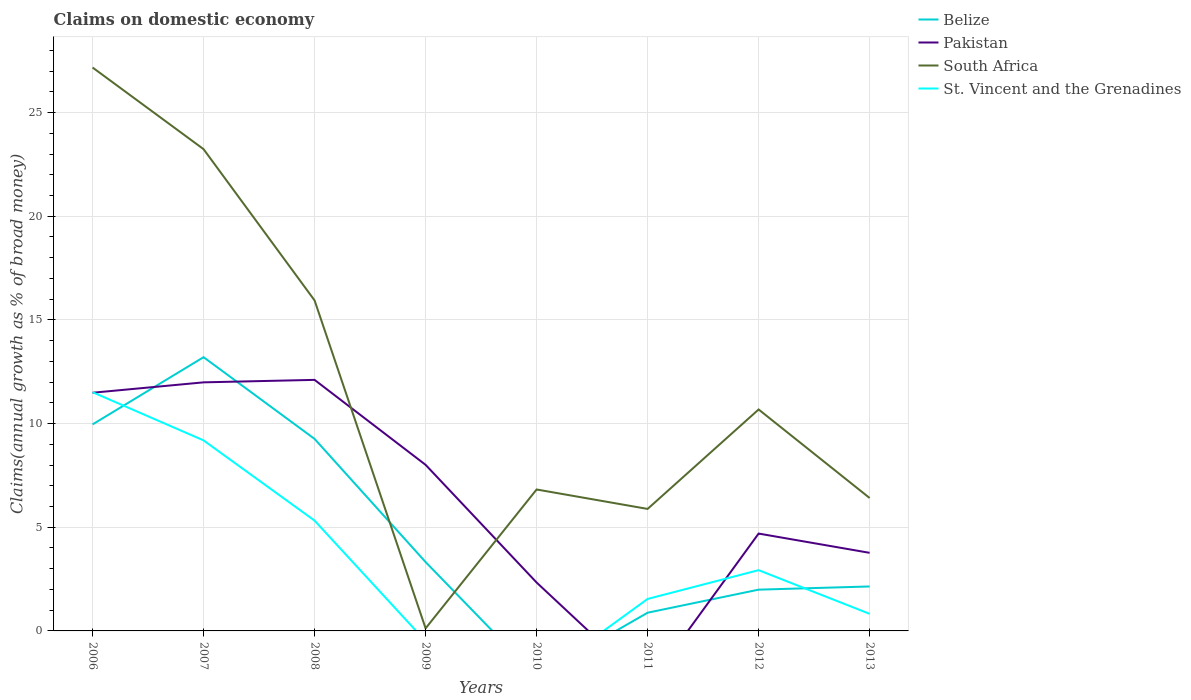How many different coloured lines are there?
Provide a succinct answer. 4. Across all years, what is the maximum percentage of broad money claimed on domestic economy in South Africa?
Keep it short and to the point. 0.12. What is the total percentage of broad money claimed on domestic economy in South Africa in the graph?
Keep it short and to the point. 21.29. What is the difference between the highest and the second highest percentage of broad money claimed on domestic economy in St. Vincent and the Grenadines?
Keep it short and to the point. 11.51. Is the percentage of broad money claimed on domestic economy in Pakistan strictly greater than the percentage of broad money claimed on domestic economy in South Africa over the years?
Offer a terse response. No. How many lines are there?
Offer a terse response. 4. How many years are there in the graph?
Your answer should be very brief. 8. Are the values on the major ticks of Y-axis written in scientific E-notation?
Provide a succinct answer. No. Does the graph contain grids?
Your answer should be very brief. Yes. How many legend labels are there?
Your answer should be very brief. 4. How are the legend labels stacked?
Provide a short and direct response. Vertical. What is the title of the graph?
Offer a terse response. Claims on domestic economy. What is the label or title of the X-axis?
Provide a succinct answer. Years. What is the label or title of the Y-axis?
Keep it short and to the point. Claims(annual growth as % of broad money). What is the Claims(annual growth as % of broad money) in Belize in 2006?
Keep it short and to the point. 9.96. What is the Claims(annual growth as % of broad money) in Pakistan in 2006?
Your answer should be compact. 11.49. What is the Claims(annual growth as % of broad money) in South Africa in 2006?
Offer a very short reply. 27.17. What is the Claims(annual growth as % of broad money) in St. Vincent and the Grenadines in 2006?
Your response must be concise. 11.51. What is the Claims(annual growth as % of broad money) in Belize in 2007?
Provide a succinct answer. 13.2. What is the Claims(annual growth as % of broad money) in Pakistan in 2007?
Give a very brief answer. 11.99. What is the Claims(annual growth as % of broad money) of South Africa in 2007?
Provide a short and direct response. 23.23. What is the Claims(annual growth as % of broad money) of St. Vincent and the Grenadines in 2007?
Provide a succinct answer. 9.19. What is the Claims(annual growth as % of broad money) in Belize in 2008?
Offer a very short reply. 9.26. What is the Claims(annual growth as % of broad money) of Pakistan in 2008?
Provide a short and direct response. 12.11. What is the Claims(annual growth as % of broad money) of South Africa in 2008?
Make the answer very short. 15.94. What is the Claims(annual growth as % of broad money) in St. Vincent and the Grenadines in 2008?
Give a very brief answer. 5.32. What is the Claims(annual growth as % of broad money) of Belize in 2009?
Give a very brief answer. 3.32. What is the Claims(annual growth as % of broad money) in Pakistan in 2009?
Provide a succinct answer. 8.01. What is the Claims(annual growth as % of broad money) of South Africa in 2009?
Your answer should be very brief. 0.12. What is the Claims(annual growth as % of broad money) of Belize in 2010?
Your answer should be very brief. 0. What is the Claims(annual growth as % of broad money) of Pakistan in 2010?
Your answer should be very brief. 2.33. What is the Claims(annual growth as % of broad money) of South Africa in 2010?
Provide a short and direct response. 6.82. What is the Claims(annual growth as % of broad money) of Belize in 2011?
Ensure brevity in your answer.  0.88. What is the Claims(annual growth as % of broad money) in South Africa in 2011?
Keep it short and to the point. 5.88. What is the Claims(annual growth as % of broad money) of St. Vincent and the Grenadines in 2011?
Your answer should be very brief. 1.54. What is the Claims(annual growth as % of broad money) in Belize in 2012?
Offer a terse response. 1.99. What is the Claims(annual growth as % of broad money) in Pakistan in 2012?
Provide a succinct answer. 4.7. What is the Claims(annual growth as % of broad money) in South Africa in 2012?
Ensure brevity in your answer.  10.68. What is the Claims(annual growth as % of broad money) in St. Vincent and the Grenadines in 2012?
Give a very brief answer. 2.93. What is the Claims(annual growth as % of broad money) of Belize in 2013?
Offer a very short reply. 2.14. What is the Claims(annual growth as % of broad money) of Pakistan in 2013?
Offer a terse response. 3.77. What is the Claims(annual growth as % of broad money) of South Africa in 2013?
Provide a succinct answer. 6.41. What is the Claims(annual growth as % of broad money) of St. Vincent and the Grenadines in 2013?
Offer a very short reply. 0.82. Across all years, what is the maximum Claims(annual growth as % of broad money) in Belize?
Your answer should be very brief. 13.2. Across all years, what is the maximum Claims(annual growth as % of broad money) of Pakistan?
Your answer should be compact. 12.11. Across all years, what is the maximum Claims(annual growth as % of broad money) in South Africa?
Provide a short and direct response. 27.17. Across all years, what is the maximum Claims(annual growth as % of broad money) of St. Vincent and the Grenadines?
Ensure brevity in your answer.  11.51. Across all years, what is the minimum Claims(annual growth as % of broad money) in Belize?
Offer a very short reply. 0. Across all years, what is the minimum Claims(annual growth as % of broad money) of Pakistan?
Your answer should be compact. 0. Across all years, what is the minimum Claims(annual growth as % of broad money) of South Africa?
Provide a succinct answer. 0.12. What is the total Claims(annual growth as % of broad money) in Belize in the graph?
Ensure brevity in your answer.  40.76. What is the total Claims(annual growth as % of broad money) of Pakistan in the graph?
Your response must be concise. 54.39. What is the total Claims(annual growth as % of broad money) of South Africa in the graph?
Ensure brevity in your answer.  96.26. What is the total Claims(annual growth as % of broad money) of St. Vincent and the Grenadines in the graph?
Ensure brevity in your answer.  31.32. What is the difference between the Claims(annual growth as % of broad money) of Belize in 2006 and that in 2007?
Your answer should be very brief. -3.24. What is the difference between the Claims(annual growth as % of broad money) of Pakistan in 2006 and that in 2007?
Ensure brevity in your answer.  -0.5. What is the difference between the Claims(annual growth as % of broad money) in South Africa in 2006 and that in 2007?
Offer a terse response. 3.94. What is the difference between the Claims(annual growth as % of broad money) in St. Vincent and the Grenadines in 2006 and that in 2007?
Ensure brevity in your answer.  2.32. What is the difference between the Claims(annual growth as % of broad money) of Belize in 2006 and that in 2008?
Offer a very short reply. 0.7. What is the difference between the Claims(annual growth as % of broad money) in Pakistan in 2006 and that in 2008?
Offer a terse response. -0.62. What is the difference between the Claims(annual growth as % of broad money) of South Africa in 2006 and that in 2008?
Make the answer very short. 11.23. What is the difference between the Claims(annual growth as % of broad money) in St. Vincent and the Grenadines in 2006 and that in 2008?
Offer a very short reply. 6.19. What is the difference between the Claims(annual growth as % of broad money) in Belize in 2006 and that in 2009?
Offer a very short reply. 6.64. What is the difference between the Claims(annual growth as % of broad money) of Pakistan in 2006 and that in 2009?
Provide a short and direct response. 3.48. What is the difference between the Claims(annual growth as % of broad money) in South Africa in 2006 and that in 2009?
Your answer should be very brief. 27.05. What is the difference between the Claims(annual growth as % of broad money) in Pakistan in 2006 and that in 2010?
Your response must be concise. 9.15. What is the difference between the Claims(annual growth as % of broad money) of South Africa in 2006 and that in 2010?
Provide a succinct answer. 20.35. What is the difference between the Claims(annual growth as % of broad money) in Belize in 2006 and that in 2011?
Your answer should be very brief. 9.08. What is the difference between the Claims(annual growth as % of broad money) in South Africa in 2006 and that in 2011?
Ensure brevity in your answer.  21.29. What is the difference between the Claims(annual growth as % of broad money) of St. Vincent and the Grenadines in 2006 and that in 2011?
Your response must be concise. 9.97. What is the difference between the Claims(annual growth as % of broad money) of Belize in 2006 and that in 2012?
Ensure brevity in your answer.  7.97. What is the difference between the Claims(annual growth as % of broad money) of Pakistan in 2006 and that in 2012?
Make the answer very short. 6.79. What is the difference between the Claims(annual growth as % of broad money) in South Africa in 2006 and that in 2012?
Ensure brevity in your answer.  16.49. What is the difference between the Claims(annual growth as % of broad money) of St. Vincent and the Grenadines in 2006 and that in 2012?
Provide a short and direct response. 8.58. What is the difference between the Claims(annual growth as % of broad money) in Belize in 2006 and that in 2013?
Your answer should be very brief. 7.81. What is the difference between the Claims(annual growth as % of broad money) in Pakistan in 2006 and that in 2013?
Ensure brevity in your answer.  7.72. What is the difference between the Claims(annual growth as % of broad money) of South Africa in 2006 and that in 2013?
Keep it short and to the point. 20.76. What is the difference between the Claims(annual growth as % of broad money) in St. Vincent and the Grenadines in 2006 and that in 2013?
Provide a succinct answer. 10.69. What is the difference between the Claims(annual growth as % of broad money) in Belize in 2007 and that in 2008?
Your answer should be compact. 3.94. What is the difference between the Claims(annual growth as % of broad money) of Pakistan in 2007 and that in 2008?
Ensure brevity in your answer.  -0.12. What is the difference between the Claims(annual growth as % of broad money) of South Africa in 2007 and that in 2008?
Offer a terse response. 7.29. What is the difference between the Claims(annual growth as % of broad money) in St. Vincent and the Grenadines in 2007 and that in 2008?
Your answer should be compact. 3.87. What is the difference between the Claims(annual growth as % of broad money) of Belize in 2007 and that in 2009?
Ensure brevity in your answer.  9.88. What is the difference between the Claims(annual growth as % of broad money) of Pakistan in 2007 and that in 2009?
Provide a succinct answer. 3.98. What is the difference between the Claims(annual growth as % of broad money) in South Africa in 2007 and that in 2009?
Give a very brief answer. 23.11. What is the difference between the Claims(annual growth as % of broad money) of Pakistan in 2007 and that in 2010?
Provide a succinct answer. 9.65. What is the difference between the Claims(annual growth as % of broad money) in South Africa in 2007 and that in 2010?
Give a very brief answer. 16.41. What is the difference between the Claims(annual growth as % of broad money) of Belize in 2007 and that in 2011?
Make the answer very short. 12.32. What is the difference between the Claims(annual growth as % of broad money) in South Africa in 2007 and that in 2011?
Offer a very short reply. 17.35. What is the difference between the Claims(annual growth as % of broad money) of St. Vincent and the Grenadines in 2007 and that in 2011?
Provide a short and direct response. 7.65. What is the difference between the Claims(annual growth as % of broad money) in Belize in 2007 and that in 2012?
Offer a terse response. 11.21. What is the difference between the Claims(annual growth as % of broad money) in Pakistan in 2007 and that in 2012?
Your response must be concise. 7.29. What is the difference between the Claims(annual growth as % of broad money) in South Africa in 2007 and that in 2012?
Your answer should be very brief. 12.55. What is the difference between the Claims(annual growth as % of broad money) in St. Vincent and the Grenadines in 2007 and that in 2012?
Provide a short and direct response. 6.26. What is the difference between the Claims(annual growth as % of broad money) of Belize in 2007 and that in 2013?
Your answer should be compact. 11.06. What is the difference between the Claims(annual growth as % of broad money) in Pakistan in 2007 and that in 2013?
Offer a very short reply. 8.22. What is the difference between the Claims(annual growth as % of broad money) of South Africa in 2007 and that in 2013?
Your answer should be compact. 16.82. What is the difference between the Claims(annual growth as % of broad money) of St. Vincent and the Grenadines in 2007 and that in 2013?
Your answer should be very brief. 8.36. What is the difference between the Claims(annual growth as % of broad money) in Belize in 2008 and that in 2009?
Offer a terse response. 5.94. What is the difference between the Claims(annual growth as % of broad money) of Pakistan in 2008 and that in 2009?
Provide a succinct answer. 4.1. What is the difference between the Claims(annual growth as % of broad money) of South Africa in 2008 and that in 2009?
Provide a succinct answer. 15.81. What is the difference between the Claims(annual growth as % of broad money) in Pakistan in 2008 and that in 2010?
Provide a succinct answer. 9.77. What is the difference between the Claims(annual growth as % of broad money) of South Africa in 2008 and that in 2010?
Ensure brevity in your answer.  9.12. What is the difference between the Claims(annual growth as % of broad money) in Belize in 2008 and that in 2011?
Provide a short and direct response. 8.38. What is the difference between the Claims(annual growth as % of broad money) of South Africa in 2008 and that in 2011?
Provide a short and direct response. 10.06. What is the difference between the Claims(annual growth as % of broad money) of St. Vincent and the Grenadines in 2008 and that in 2011?
Keep it short and to the point. 3.78. What is the difference between the Claims(annual growth as % of broad money) in Belize in 2008 and that in 2012?
Make the answer very short. 7.27. What is the difference between the Claims(annual growth as % of broad money) of Pakistan in 2008 and that in 2012?
Keep it short and to the point. 7.41. What is the difference between the Claims(annual growth as % of broad money) of South Africa in 2008 and that in 2012?
Ensure brevity in your answer.  5.26. What is the difference between the Claims(annual growth as % of broad money) in St. Vincent and the Grenadines in 2008 and that in 2012?
Keep it short and to the point. 2.39. What is the difference between the Claims(annual growth as % of broad money) of Belize in 2008 and that in 2013?
Ensure brevity in your answer.  7.12. What is the difference between the Claims(annual growth as % of broad money) in Pakistan in 2008 and that in 2013?
Offer a very short reply. 8.34. What is the difference between the Claims(annual growth as % of broad money) of South Africa in 2008 and that in 2013?
Make the answer very short. 9.53. What is the difference between the Claims(annual growth as % of broad money) of St. Vincent and the Grenadines in 2008 and that in 2013?
Keep it short and to the point. 4.5. What is the difference between the Claims(annual growth as % of broad money) of Pakistan in 2009 and that in 2010?
Offer a very short reply. 5.68. What is the difference between the Claims(annual growth as % of broad money) of South Africa in 2009 and that in 2010?
Ensure brevity in your answer.  -6.7. What is the difference between the Claims(annual growth as % of broad money) in Belize in 2009 and that in 2011?
Ensure brevity in your answer.  2.44. What is the difference between the Claims(annual growth as % of broad money) in South Africa in 2009 and that in 2011?
Provide a short and direct response. -5.76. What is the difference between the Claims(annual growth as % of broad money) in Belize in 2009 and that in 2012?
Keep it short and to the point. 1.33. What is the difference between the Claims(annual growth as % of broad money) of Pakistan in 2009 and that in 2012?
Give a very brief answer. 3.31. What is the difference between the Claims(annual growth as % of broad money) of South Africa in 2009 and that in 2012?
Provide a short and direct response. -10.56. What is the difference between the Claims(annual growth as % of broad money) of Belize in 2009 and that in 2013?
Keep it short and to the point. 1.18. What is the difference between the Claims(annual growth as % of broad money) of Pakistan in 2009 and that in 2013?
Keep it short and to the point. 4.24. What is the difference between the Claims(annual growth as % of broad money) of South Africa in 2009 and that in 2013?
Ensure brevity in your answer.  -6.29. What is the difference between the Claims(annual growth as % of broad money) in South Africa in 2010 and that in 2011?
Keep it short and to the point. 0.94. What is the difference between the Claims(annual growth as % of broad money) of Pakistan in 2010 and that in 2012?
Your answer should be compact. -2.36. What is the difference between the Claims(annual growth as % of broad money) of South Africa in 2010 and that in 2012?
Your answer should be compact. -3.86. What is the difference between the Claims(annual growth as % of broad money) in Pakistan in 2010 and that in 2013?
Keep it short and to the point. -1.43. What is the difference between the Claims(annual growth as % of broad money) of South Africa in 2010 and that in 2013?
Your response must be concise. 0.41. What is the difference between the Claims(annual growth as % of broad money) of Belize in 2011 and that in 2012?
Your answer should be compact. -1.11. What is the difference between the Claims(annual growth as % of broad money) in South Africa in 2011 and that in 2012?
Provide a short and direct response. -4.8. What is the difference between the Claims(annual growth as % of broad money) of St. Vincent and the Grenadines in 2011 and that in 2012?
Your response must be concise. -1.39. What is the difference between the Claims(annual growth as % of broad money) in Belize in 2011 and that in 2013?
Give a very brief answer. -1.27. What is the difference between the Claims(annual growth as % of broad money) in South Africa in 2011 and that in 2013?
Your response must be concise. -0.53. What is the difference between the Claims(annual growth as % of broad money) in St. Vincent and the Grenadines in 2011 and that in 2013?
Your answer should be very brief. 0.72. What is the difference between the Claims(annual growth as % of broad money) of Belize in 2012 and that in 2013?
Offer a very short reply. -0.15. What is the difference between the Claims(annual growth as % of broad money) in Pakistan in 2012 and that in 2013?
Keep it short and to the point. 0.93. What is the difference between the Claims(annual growth as % of broad money) in South Africa in 2012 and that in 2013?
Provide a succinct answer. 4.27. What is the difference between the Claims(annual growth as % of broad money) in St. Vincent and the Grenadines in 2012 and that in 2013?
Provide a succinct answer. 2.11. What is the difference between the Claims(annual growth as % of broad money) in Belize in 2006 and the Claims(annual growth as % of broad money) in Pakistan in 2007?
Provide a short and direct response. -2.03. What is the difference between the Claims(annual growth as % of broad money) of Belize in 2006 and the Claims(annual growth as % of broad money) of South Africa in 2007?
Offer a terse response. -13.27. What is the difference between the Claims(annual growth as % of broad money) of Belize in 2006 and the Claims(annual growth as % of broad money) of St. Vincent and the Grenadines in 2007?
Offer a terse response. 0.77. What is the difference between the Claims(annual growth as % of broad money) of Pakistan in 2006 and the Claims(annual growth as % of broad money) of South Africa in 2007?
Provide a succinct answer. -11.75. What is the difference between the Claims(annual growth as % of broad money) of Pakistan in 2006 and the Claims(annual growth as % of broad money) of St. Vincent and the Grenadines in 2007?
Your response must be concise. 2.3. What is the difference between the Claims(annual growth as % of broad money) in South Africa in 2006 and the Claims(annual growth as % of broad money) in St. Vincent and the Grenadines in 2007?
Keep it short and to the point. 17.98. What is the difference between the Claims(annual growth as % of broad money) of Belize in 2006 and the Claims(annual growth as % of broad money) of Pakistan in 2008?
Provide a succinct answer. -2.15. What is the difference between the Claims(annual growth as % of broad money) of Belize in 2006 and the Claims(annual growth as % of broad money) of South Africa in 2008?
Offer a terse response. -5.98. What is the difference between the Claims(annual growth as % of broad money) in Belize in 2006 and the Claims(annual growth as % of broad money) in St. Vincent and the Grenadines in 2008?
Make the answer very short. 4.64. What is the difference between the Claims(annual growth as % of broad money) in Pakistan in 2006 and the Claims(annual growth as % of broad money) in South Africa in 2008?
Provide a short and direct response. -4.45. What is the difference between the Claims(annual growth as % of broad money) in Pakistan in 2006 and the Claims(annual growth as % of broad money) in St. Vincent and the Grenadines in 2008?
Make the answer very short. 6.17. What is the difference between the Claims(annual growth as % of broad money) in South Africa in 2006 and the Claims(annual growth as % of broad money) in St. Vincent and the Grenadines in 2008?
Ensure brevity in your answer.  21.85. What is the difference between the Claims(annual growth as % of broad money) in Belize in 2006 and the Claims(annual growth as % of broad money) in Pakistan in 2009?
Ensure brevity in your answer.  1.95. What is the difference between the Claims(annual growth as % of broad money) of Belize in 2006 and the Claims(annual growth as % of broad money) of South Africa in 2009?
Offer a terse response. 9.84. What is the difference between the Claims(annual growth as % of broad money) of Pakistan in 2006 and the Claims(annual growth as % of broad money) of South Africa in 2009?
Your answer should be very brief. 11.36. What is the difference between the Claims(annual growth as % of broad money) of Belize in 2006 and the Claims(annual growth as % of broad money) of Pakistan in 2010?
Ensure brevity in your answer.  7.62. What is the difference between the Claims(annual growth as % of broad money) of Belize in 2006 and the Claims(annual growth as % of broad money) of South Africa in 2010?
Provide a succinct answer. 3.14. What is the difference between the Claims(annual growth as % of broad money) in Pakistan in 2006 and the Claims(annual growth as % of broad money) in South Africa in 2010?
Your response must be concise. 4.67. What is the difference between the Claims(annual growth as % of broad money) of Belize in 2006 and the Claims(annual growth as % of broad money) of South Africa in 2011?
Make the answer very short. 4.08. What is the difference between the Claims(annual growth as % of broad money) of Belize in 2006 and the Claims(annual growth as % of broad money) of St. Vincent and the Grenadines in 2011?
Ensure brevity in your answer.  8.42. What is the difference between the Claims(annual growth as % of broad money) of Pakistan in 2006 and the Claims(annual growth as % of broad money) of South Africa in 2011?
Keep it short and to the point. 5.6. What is the difference between the Claims(annual growth as % of broad money) in Pakistan in 2006 and the Claims(annual growth as % of broad money) in St. Vincent and the Grenadines in 2011?
Keep it short and to the point. 9.94. What is the difference between the Claims(annual growth as % of broad money) in South Africa in 2006 and the Claims(annual growth as % of broad money) in St. Vincent and the Grenadines in 2011?
Provide a succinct answer. 25.63. What is the difference between the Claims(annual growth as % of broad money) in Belize in 2006 and the Claims(annual growth as % of broad money) in Pakistan in 2012?
Offer a terse response. 5.26. What is the difference between the Claims(annual growth as % of broad money) in Belize in 2006 and the Claims(annual growth as % of broad money) in South Africa in 2012?
Your answer should be very brief. -0.72. What is the difference between the Claims(annual growth as % of broad money) in Belize in 2006 and the Claims(annual growth as % of broad money) in St. Vincent and the Grenadines in 2012?
Your response must be concise. 7.03. What is the difference between the Claims(annual growth as % of broad money) of Pakistan in 2006 and the Claims(annual growth as % of broad money) of South Africa in 2012?
Your answer should be very brief. 0.81. What is the difference between the Claims(annual growth as % of broad money) of Pakistan in 2006 and the Claims(annual growth as % of broad money) of St. Vincent and the Grenadines in 2012?
Offer a terse response. 8.56. What is the difference between the Claims(annual growth as % of broad money) of South Africa in 2006 and the Claims(annual growth as % of broad money) of St. Vincent and the Grenadines in 2012?
Provide a succinct answer. 24.24. What is the difference between the Claims(annual growth as % of broad money) of Belize in 2006 and the Claims(annual growth as % of broad money) of Pakistan in 2013?
Your answer should be compact. 6.19. What is the difference between the Claims(annual growth as % of broad money) in Belize in 2006 and the Claims(annual growth as % of broad money) in South Africa in 2013?
Keep it short and to the point. 3.55. What is the difference between the Claims(annual growth as % of broad money) in Belize in 2006 and the Claims(annual growth as % of broad money) in St. Vincent and the Grenadines in 2013?
Provide a short and direct response. 9.13. What is the difference between the Claims(annual growth as % of broad money) of Pakistan in 2006 and the Claims(annual growth as % of broad money) of South Africa in 2013?
Your response must be concise. 5.08. What is the difference between the Claims(annual growth as % of broad money) of Pakistan in 2006 and the Claims(annual growth as % of broad money) of St. Vincent and the Grenadines in 2013?
Keep it short and to the point. 10.66. What is the difference between the Claims(annual growth as % of broad money) of South Africa in 2006 and the Claims(annual growth as % of broad money) of St. Vincent and the Grenadines in 2013?
Provide a short and direct response. 26.35. What is the difference between the Claims(annual growth as % of broad money) of Belize in 2007 and the Claims(annual growth as % of broad money) of Pakistan in 2008?
Keep it short and to the point. 1.09. What is the difference between the Claims(annual growth as % of broad money) in Belize in 2007 and the Claims(annual growth as % of broad money) in South Africa in 2008?
Your answer should be very brief. -2.74. What is the difference between the Claims(annual growth as % of broad money) of Belize in 2007 and the Claims(annual growth as % of broad money) of St. Vincent and the Grenadines in 2008?
Offer a terse response. 7.88. What is the difference between the Claims(annual growth as % of broad money) of Pakistan in 2007 and the Claims(annual growth as % of broad money) of South Africa in 2008?
Your answer should be very brief. -3.95. What is the difference between the Claims(annual growth as % of broad money) of Pakistan in 2007 and the Claims(annual growth as % of broad money) of St. Vincent and the Grenadines in 2008?
Your answer should be very brief. 6.67. What is the difference between the Claims(annual growth as % of broad money) of South Africa in 2007 and the Claims(annual growth as % of broad money) of St. Vincent and the Grenadines in 2008?
Your response must be concise. 17.91. What is the difference between the Claims(annual growth as % of broad money) of Belize in 2007 and the Claims(annual growth as % of broad money) of Pakistan in 2009?
Offer a terse response. 5.19. What is the difference between the Claims(annual growth as % of broad money) of Belize in 2007 and the Claims(annual growth as % of broad money) of South Africa in 2009?
Make the answer very short. 13.08. What is the difference between the Claims(annual growth as % of broad money) of Pakistan in 2007 and the Claims(annual growth as % of broad money) of South Africa in 2009?
Offer a very short reply. 11.86. What is the difference between the Claims(annual growth as % of broad money) of Belize in 2007 and the Claims(annual growth as % of broad money) of Pakistan in 2010?
Ensure brevity in your answer.  10.87. What is the difference between the Claims(annual growth as % of broad money) of Belize in 2007 and the Claims(annual growth as % of broad money) of South Africa in 2010?
Offer a very short reply. 6.38. What is the difference between the Claims(annual growth as % of broad money) of Pakistan in 2007 and the Claims(annual growth as % of broad money) of South Africa in 2010?
Provide a short and direct response. 5.17. What is the difference between the Claims(annual growth as % of broad money) of Belize in 2007 and the Claims(annual growth as % of broad money) of South Africa in 2011?
Give a very brief answer. 7.32. What is the difference between the Claims(annual growth as % of broad money) of Belize in 2007 and the Claims(annual growth as % of broad money) of St. Vincent and the Grenadines in 2011?
Your response must be concise. 11.66. What is the difference between the Claims(annual growth as % of broad money) in Pakistan in 2007 and the Claims(annual growth as % of broad money) in South Africa in 2011?
Your answer should be compact. 6.1. What is the difference between the Claims(annual growth as % of broad money) in Pakistan in 2007 and the Claims(annual growth as % of broad money) in St. Vincent and the Grenadines in 2011?
Make the answer very short. 10.45. What is the difference between the Claims(annual growth as % of broad money) of South Africa in 2007 and the Claims(annual growth as % of broad money) of St. Vincent and the Grenadines in 2011?
Offer a terse response. 21.69. What is the difference between the Claims(annual growth as % of broad money) of Belize in 2007 and the Claims(annual growth as % of broad money) of Pakistan in 2012?
Your response must be concise. 8.51. What is the difference between the Claims(annual growth as % of broad money) in Belize in 2007 and the Claims(annual growth as % of broad money) in South Africa in 2012?
Your response must be concise. 2.52. What is the difference between the Claims(annual growth as % of broad money) of Belize in 2007 and the Claims(annual growth as % of broad money) of St. Vincent and the Grenadines in 2012?
Your answer should be very brief. 10.27. What is the difference between the Claims(annual growth as % of broad money) of Pakistan in 2007 and the Claims(annual growth as % of broad money) of South Africa in 2012?
Offer a terse response. 1.31. What is the difference between the Claims(annual growth as % of broad money) of Pakistan in 2007 and the Claims(annual growth as % of broad money) of St. Vincent and the Grenadines in 2012?
Make the answer very short. 9.06. What is the difference between the Claims(annual growth as % of broad money) in South Africa in 2007 and the Claims(annual growth as % of broad money) in St. Vincent and the Grenadines in 2012?
Ensure brevity in your answer.  20.3. What is the difference between the Claims(annual growth as % of broad money) in Belize in 2007 and the Claims(annual growth as % of broad money) in Pakistan in 2013?
Your answer should be compact. 9.44. What is the difference between the Claims(annual growth as % of broad money) in Belize in 2007 and the Claims(annual growth as % of broad money) in South Africa in 2013?
Ensure brevity in your answer.  6.79. What is the difference between the Claims(annual growth as % of broad money) of Belize in 2007 and the Claims(annual growth as % of broad money) of St. Vincent and the Grenadines in 2013?
Give a very brief answer. 12.38. What is the difference between the Claims(annual growth as % of broad money) of Pakistan in 2007 and the Claims(annual growth as % of broad money) of South Africa in 2013?
Ensure brevity in your answer.  5.58. What is the difference between the Claims(annual growth as % of broad money) in Pakistan in 2007 and the Claims(annual growth as % of broad money) in St. Vincent and the Grenadines in 2013?
Provide a succinct answer. 11.16. What is the difference between the Claims(annual growth as % of broad money) of South Africa in 2007 and the Claims(annual growth as % of broad money) of St. Vincent and the Grenadines in 2013?
Your answer should be compact. 22.41. What is the difference between the Claims(annual growth as % of broad money) of Belize in 2008 and the Claims(annual growth as % of broad money) of Pakistan in 2009?
Your answer should be very brief. 1.25. What is the difference between the Claims(annual growth as % of broad money) of Belize in 2008 and the Claims(annual growth as % of broad money) of South Africa in 2009?
Keep it short and to the point. 9.14. What is the difference between the Claims(annual growth as % of broad money) in Pakistan in 2008 and the Claims(annual growth as % of broad money) in South Africa in 2009?
Ensure brevity in your answer.  11.98. What is the difference between the Claims(annual growth as % of broad money) in Belize in 2008 and the Claims(annual growth as % of broad money) in Pakistan in 2010?
Offer a very short reply. 6.93. What is the difference between the Claims(annual growth as % of broad money) of Belize in 2008 and the Claims(annual growth as % of broad money) of South Africa in 2010?
Your response must be concise. 2.44. What is the difference between the Claims(annual growth as % of broad money) of Pakistan in 2008 and the Claims(annual growth as % of broad money) of South Africa in 2010?
Your answer should be very brief. 5.29. What is the difference between the Claims(annual growth as % of broad money) of Belize in 2008 and the Claims(annual growth as % of broad money) of South Africa in 2011?
Make the answer very short. 3.38. What is the difference between the Claims(annual growth as % of broad money) of Belize in 2008 and the Claims(annual growth as % of broad money) of St. Vincent and the Grenadines in 2011?
Keep it short and to the point. 7.72. What is the difference between the Claims(annual growth as % of broad money) in Pakistan in 2008 and the Claims(annual growth as % of broad money) in South Africa in 2011?
Offer a very short reply. 6.22. What is the difference between the Claims(annual growth as % of broad money) of Pakistan in 2008 and the Claims(annual growth as % of broad money) of St. Vincent and the Grenadines in 2011?
Keep it short and to the point. 10.56. What is the difference between the Claims(annual growth as % of broad money) of South Africa in 2008 and the Claims(annual growth as % of broad money) of St. Vincent and the Grenadines in 2011?
Ensure brevity in your answer.  14.4. What is the difference between the Claims(annual growth as % of broad money) in Belize in 2008 and the Claims(annual growth as % of broad money) in Pakistan in 2012?
Your response must be concise. 4.56. What is the difference between the Claims(annual growth as % of broad money) of Belize in 2008 and the Claims(annual growth as % of broad money) of South Africa in 2012?
Offer a very short reply. -1.42. What is the difference between the Claims(annual growth as % of broad money) of Belize in 2008 and the Claims(annual growth as % of broad money) of St. Vincent and the Grenadines in 2012?
Give a very brief answer. 6.33. What is the difference between the Claims(annual growth as % of broad money) of Pakistan in 2008 and the Claims(annual growth as % of broad money) of South Africa in 2012?
Ensure brevity in your answer.  1.43. What is the difference between the Claims(annual growth as % of broad money) of Pakistan in 2008 and the Claims(annual growth as % of broad money) of St. Vincent and the Grenadines in 2012?
Keep it short and to the point. 9.18. What is the difference between the Claims(annual growth as % of broad money) in South Africa in 2008 and the Claims(annual growth as % of broad money) in St. Vincent and the Grenadines in 2012?
Your answer should be very brief. 13.01. What is the difference between the Claims(annual growth as % of broad money) in Belize in 2008 and the Claims(annual growth as % of broad money) in Pakistan in 2013?
Your response must be concise. 5.49. What is the difference between the Claims(annual growth as % of broad money) in Belize in 2008 and the Claims(annual growth as % of broad money) in South Africa in 2013?
Your response must be concise. 2.85. What is the difference between the Claims(annual growth as % of broad money) in Belize in 2008 and the Claims(annual growth as % of broad money) in St. Vincent and the Grenadines in 2013?
Provide a succinct answer. 8.44. What is the difference between the Claims(annual growth as % of broad money) in Pakistan in 2008 and the Claims(annual growth as % of broad money) in South Africa in 2013?
Offer a terse response. 5.7. What is the difference between the Claims(annual growth as % of broad money) of Pakistan in 2008 and the Claims(annual growth as % of broad money) of St. Vincent and the Grenadines in 2013?
Your response must be concise. 11.28. What is the difference between the Claims(annual growth as % of broad money) of South Africa in 2008 and the Claims(annual growth as % of broad money) of St. Vincent and the Grenadines in 2013?
Provide a succinct answer. 15.11. What is the difference between the Claims(annual growth as % of broad money) in Belize in 2009 and the Claims(annual growth as % of broad money) in Pakistan in 2010?
Your answer should be compact. 0.99. What is the difference between the Claims(annual growth as % of broad money) in Belize in 2009 and the Claims(annual growth as % of broad money) in South Africa in 2010?
Make the answer very short. -3.5. What is the difference between the Claims(annual growth as % of broad money) of Pakistan in 2009 and the Claims(annual growth as % of broad money) of South Africa in 2010?
Provide a short and direct response. 1.19. What is the difference between the Claims(annual growth as % of broad money) in Belize in 2009 and the Claims(annual growth as % of broad money) in South Africa in 2011?
Give a very brief answer. -2.56. What is the difference between the Claims(annual growth as % of broad money) of Belize in 2009 and the Claims(annual growth as % of broad money) of St. Vincent and the Grenadines in 2011?
Your answer should be very brief. 1.78. What is the difference between the Claims(annual growth as % of broad money) of Pakistan in 2009 and the Claims(annual growth as % of broad money) of South Africa in 2011?
Offer a very short reply. 2.13. What is the difference between the Claims(annual growth as % of broad money) in Pakistan in 2009 and the Claims(annual growth as % of broad money) in St. Vincent and the Grenadines in 2011?
Provide a short and direct response. 6.47. What is the difference between the Claims(annual growth as % of broad money) in South Africa in 2009 and the Claims(annual growth as % of broad money) in St. Vincent and the Grenadines in 2011?
Keep it short and to the point. -1.42. What is the difference between the Claims(annual growth as % of broad money) of Belize in 2009 and the Claims(annual growth as % of broad money) of Pakistan in 2012?
Keep it short and to the point. -1.37. What is the difference between the Claims(annual growth as % of broad money) in Belize in 2009 and the Claims(annual growth as % of broad money) in South Africa in 2012?
Offer a terse response. -7.36. What is the difference between the Claims(annual growth as % of broad money) of Belize in 2009 and the Claims(annual growth as % of broad money) of St. Vincent and the Grenadines in 2012?
Give a very brief answer. 0.39. What is the difference between the Claims(annual growth as % of broad money) in Pakistan in 2009 and the Claims(annual growth as % of broad money) in South Africa in 2012?
Your response must be concise. -2.67. What is the difference between the Claims(annual growth as % of broad money) in Pakistan in 2009 and the Claims(annual growth as % of broad money) in St. Vincent and the Grenadines in 2012?
Provide a succinct answer. 5.08. What is the difference between the Claims(annual growth as % of broad money) of South Africa in 2009 and the Claims(annual growth as % of broad money) of St. Vincent and the Grenadines in 2012?
Make the answer very short. -2.81. What is the difference between the Claims(annual growth as % of broad money) of Belize in 2009 and the Claims(annual growth as % of broad money) of Pakistan in 2013?
Your response must be concise. -0.44. What is the difference between the Claims(annual growth as % of broad money) in Belize in 2009 and the Claims(annual growth as % of broad money) in South Africa in 2013?
Make the answer very short. -3.09. What is the difference between the Claims(annual growth as % of broad money) in Belize in 2009 and the Claims(annual growth as % of broad money) in St. Vincent and the Grenadines in 2013?
Offer a terse response. 2.5. What is the difference between the Claims(annual growth as % of broad money) in Pakistan in 2009 and the Claims(annual growth as % of broad money) in South Africa in 2013?
Ensure brevity in your answer.  1.6. What is the difference between the Claims(annual growth as % of broad money) of Pakistan in 2009 and the Claims(annual growth as % of broad money) of St. Vincent and the Grenadines in 2013?
Make the answer very short. 7.19. What is the difference between the Claims(annual growth as % of broad money) in South Africa in 2009 and the Claims(annual growth as % of broad money) in St. Vincent and the Grenadines in 2013?
Your response must be concise. -0.7. What is the difference between the Claims(annual growth as % of broad money) in Pakistan in 2010 and the Claims(annual growth as % of broad money) in South Africa in 2011?
Offer a very short reply. -3.55. What is the difference between the Claims(annual growth as % of broad money) of Pakistan in 2010 and the Claims(annual growth as % of broad money) of St. Vincent and the Grenadines in 2011?
Offer a terse response. 0.79. What is the difference between the Claims(annual growth as % of broad money) of South Africa in 2010 and the Claims(annual growth as % of broad money) of St. Vincent and the Grenadines in 2011?
Ensure brevity in your answer.  5.28. What is the difference between the Claims(annual growth as % of broad money) in Pakistan in 2010 and the Claims(annual growth as % of broad money) in South Africa in 2012?
Make the answer very short. -8.34. What is the difference between the Claims(annual growth as % of broad money) in Pakistan in 2010 and the Claims(annual growth as % of broad money) in St. Vincent and the Grenadines in 2012?
Provide a short and direct response. -0.6. What is the difference between the Claims(annual growth as % of broad money) in South Africa in 2010 and the Claims(annual growth as % of broad money) in St. Vincent and the Grenadines in 2012?
Provide a succinct answer. 3.89. What is the difference between the Claims(annual growth as % of broad money) of Pakistan in 2010 and the Claims(annual growth as % of broad money) of South Africa in 2013?
Ensure brevity in your answer.  -4.08. What is the difference between the Claims(annual growth as % of broad money) of Pakistan in 2010 and the Claims(annual growth as % of broad money) of St. Vincent and the Grenadines in 2013?
Offer a very short reply. 1.51. What is the difference between the Claims(annual growth as % of broad money) of South Africa in 2010 and the Claims(annual growth as % of broad money) of St. Vincent and the Grenadines in 2013?
Your response must be concise. 6. What is the difference between the Claims(annual growth as % of broad money) of Belize in 2011 and the Claims(annual growth as % of broad money) of Pakistan in 2012?
Your answer should be very brief. -3.82. What is the difference between the Claims(annual growth as % of broad money) of Belize in 2011 and the Claims(annual growth as % of broad money) of South Africa in 2012?
Give a very brief answer. -9.8. What is the difference between the Claims(annual growth as % of broad money) of Belize in 2011 and the Claims(annual growth as % of broad money) of St. Vincent and the Grenadines in 2012?
Your response must be concise. -2.05. What is the difference between the Claims(annual growth as % of broad money) of South Africa in 2011 and the Claims(annual growth as % of broad money) of St. Vincent and the Grenadines in 2012?
Make the answer very short. 2.95. What is the difference between the Claims(annual growth as % of broad money) of Belize in 2011 and the Claims(annual growth as % of broad money) of Pakistan in 2013?
Give a very brief answer. -2.89. What is the difference between the Claims(annual growth as % of broad money) of Belize in 2011 and the Claims(annual growth as % of broad money) of South Africa in 2013?
Ensure brevity in your answer.  -5.53. What is the difference between the Claims(annual growth as % of broad money) in Belize in 2011 and the Claims(annual growth as % of broad money) in St. Vincent and the Grenadines in 2013?
Your answer should be compact. 0.05. What is the difference between the Claims(annual growth as % of broad money) in South Africa in 2011 and the Claims(annual growth as % of broad money) in St. Vincent and the Grenadines in 2013?
Provide a short and direct response. 5.06. What is the difference between the Claims(annual growth as % of broad money) of Belize in 2012 and the Claims(annual growth as % of broad money) of Pakistan in 2013?
Keep it short and to the point. -1.78. What is the difference between the Claims(annual growth as % of broad money) in Belize in 2012 and the Claims(annual growth as % of broad money) in South Africa in 2013?
Your answer should be compact. -4.42. What is the difference between the Claims(annual growth as % of broad money) in Belize in 2012 and the Claims(annual growth as % of broad money) in St. Vincent and the Grenadines in 2013?
Ensure brevity in your answer.  1.17. What is the difference between the Claims(annual growth as % of broad money) in Pakistan in 2012 and the Claims(annual growth as % of broad money) in South Africa in 2013?
Provide a succinct answer. -1.71. What is the difference between the Claims(annual growth as % of broad money) of Pakistan in 2012 and the Claims(annual growth as % of broad money) of St. Vincent and the Grenadines in 2013?
Your answer should be compact. 3.87. What is the difference between the Claims(annual growth as % of broad money) of South Africa in 2012 and the Claims(annual growth as % of broad money) of St. Vincent and the Grenadines in 2013?
Provide a short and direct response. 9.85. What is the average Claims(annual growth as % of broad money) in Belize per year?
Offer a very short reply. 5.09. What is the average Claims(annual growth as % of broad money) of Pakistan per year?
Keep it short and to the point. 6.8. What is the average Claims(annual growth as % of broad money) of South Africa per year?
Your answer should be compact. 12.03. What is the average Claims(annual growth as % of broad money) of St. Vincent and the Grenadines per year?
Ensure brevity in your answer.  3.92. In the year 2006, what is the difference between the Claims(annual growth as % of broad money) of Belize and Claims(annual growth as % of broad money) of Pakistan?
Provide a succinct answer. -1.53. In the year 2006, what is the difference between the Claims(annual growth as % of broad money) in Belize and Claims(annual growth as % of broad money) in South Africa?
Your response must be concise. -17.21. In the year 2006, what is the difference between the Claims(annual growth as % of broad money) of Belize and Claims(annual growth as % of broad money) of St. Vincent and the Grenadines?
Your answer should be very brief. -1.55. In the year 2006, what is the difference between the Claims(annual growth as % of broad money) in Pakistan and Claims(annual growth as % of broad money) in South Africa?
Your answer should be very brief. -15.69. In the year 2006, what is the difference between the Claims(annual growth as % of broad money) in Pakistan and Claims(annual growth as % of broad money) in St. Vincent and the Grenadines?
Your answer should be very brief. -0.03. In the year 2006, what is the difference between the Claims(annual growth as % of broad money) of South Africa and Claims(annual growth as % of broad money) of St. Vincent and the Grenadines?
Give a very brief answer. 15.66. In the year 2007, what is the difference between the Claims(annual growth as % of broad money) of Belize and Claims(annual growth as % of broad money) of Pakistan?
Your answer should be compact. 1.21. In the year 2007, what is the difference between the Claims(annual growth as % of broad money) of Belize and Claims(annual growth as % of broad money) of South Africa?
Your answer should be very brief. -10.03. In the year 2007, what is the difference between the Claims(annual growth as % of broad money) in Belize and Claims(annual growth as % of broad money) in St. Vincent and the Grenadines?
Make the answer very short. 4.01. In the year 2007, what is the difference between the Claims(annual growth as % of broad money) in Pakistan and Claims(annual growth as % of broad money) in South Africa?
Provide a short and direct response. -11.25. In the year 2007, what is the difference between the Claims(annual growth as % of broad money) in Pakistan and Claims(annual growth as % of broad money) in St. Vincent and the Grenadines?
Ensure brevity in your answer.  2.8. In the year 2007, what is the difference between the Claims(annual growth as % of broad money) in South Africa and Claims(annual growth as % of broad money) in St. Vincent and the Grenadines?
Your response must be concise. 14.04. In the year 2008, what is the difference between the Claims(annual growth as % of broad money) of Belize and Claims(annual growth as % of broad money) of Pakistan?
Your response must be concise. -2.85. In the year 2008, what is the difference between the Claims(annual growth as % of broad money) of Belize and Claims(annual growth as % of broad money) of South Africa?
Your answer should be very brief. -6.68. In the year 2008, what is the difference between the Claims(annual growth as % of broad money) in Belize and Claims(annual growth as % of broad money) in St. Vincent and the Grenadines?
Give a very brief answer. 3.94. In the year 2008, what is the difference between the Claims(annual growth as % of broad money) of Pakistan and Claims(annual growth as % of broad money) of South Africa?
Your response must be concise. -3.83. In the year 2008, what is the difference between the Claims(annual growth as % of broad money) in Pakistan and Claims(annual growth as % of broad money) in St. Vincent and the Grenadines?
Your answer should be compact. 6.79. In the year 2008, what is the difference between the Claims(annual growth as % of broad money) of South Africa and Claims(annual growth as % of broad money) of St. Vincent and the Grenadines?
Ensure brevity in your answer.  10.62. In the year 2009, what is the difference between the Claims(annual growth as % of broad money) in Belize and Claims(annual growth as % of broad money) in Pakistan?
Provide a short and direct response. -4.69. In the year 2009, what is the difference between the Claims(annual growth as % of broad money) in Belize and Claims(annual growth as % of broad money) in South Africa?
Give a very brief answer. 3.2. In the year 2009, what is the difference between the Claims(annual growth as % of broad money) in Pakistan and Claims(annual growth as % of broad money) in South Africa?
Provide a succinct answer. 7.89. In the year 2010, what is the difference between the Claims(annual growth as % of broad money) of Pakistan and Claims(annual growth as % of broad money) of South Africa?
Keep it short and to the point. -4.49. In the year 2011, what is the difference between the Claims(annual growth as % of broad money) in Belize and Claims(annual growth as % of broad money) in South Africa?
Ensure brevity in your answer.  -5.01. In the year 2011, what is the difference between the Claims(annual growth as % of broad money) in Belize and Claims(annual growth as % of broad money) in St. Vincent and the Grenadines?
Your response must be concise. -0.66. In the year 2011, what is the difference between the Claims(annual growth as % of broad money) of South Africa and Claims(annual growth as % of broad money) of St. Vincent and the Grenadines?
Provide a short and direct response. 4.34. In the year 2012, what is the difference between the Claims(annual growth as % of broad money) in Belize and Claims(annual growth as % of broad money) in Pakistan?
Offer a very short reply. -2.71. In the year 2012, what is the difference between the Claims(annual growth as % of broad money) of Belize and Claims(annual growth as % of broad money) of South Africa?
Make the answer very short. -8.69. In the year 2012, what is the difference between the Claims(annual growth as % of broad money) in Belize and Claims(annual growth as % of broad money) in St. Vincent and the Grenadines?
Offer a terse response. -0.94. In the year 2012, what is the difference between the Claims(annual growth as % of broad money) of Pakistan and Claims(annual growth as % of broad money) of South Africa?
Keep it short and to the point. -5.98. In the year 2012, what is the difference between the Claims(annual growth as % of broad money) in Pakistan and Claims(annual growth as % of broad money) in St. Vincent and the Grenadines?
Keep it short and to the point. 1.77. In the year 2012, what is the difference between the Claims(annual growth as % of broad money) in South Africa and Claims(annual growth as % of broad money) in St. Vincent and the Grenadines?
Make the answer very short. 7.75. In the year 2013, what is the difference between the Claims(annual growth as % of broad money) in Belize and Claims(annual growth as % of broad money) in Pakistan?
Ensure brevity in your answer.  -1.62. In the year 2013, what is the difference between the Claims(annual growth as % of broad money) of Belize and Claims(annual growth as % of broad money) of South Africa?
Make the answer very short. -4.27. In the year 2013, what is the difference between the Claims(annual growth as % of broad money) of Belize and Claims(annual growth as % of broad money) of St. Vincent and the Grenadines?
Provide a short and direct response. 1.32. In the year 2013, what is the difference between the Claims(annual growth as % of broad money) of Pakistan and Claims(annual growth as % of broad money) of South Africa?
Ensure brevity in your answer.  -2.64. In the year 2013, what is the difference between the Claims(annual growth as % of broad money) of Pakistan and Claims(annual growth as % of broad money) of St. Vincent and the Grenadines?
Provide a succinct answer. 2.94. In the year 2013, what is the difference between the Claims(annual growth as % of broad money) of South Africa and Claims(annual growth as % of broad money) of St. Vincent and the Grenadines?
Your response must be concise. 5.59. What is the ratio of the Claims(annual growth as % of broad money) of Belize in 2006 to that in 2007?
Offer a terse response. 0.75. What is the ratio of the Claims(annual growth as % of broad money) in Pakistan in 2006 to that in 2007?
Your response must be concise. 0.96. What is the ratio of the Claims(annual growth as % of broad money) of South Africa in 2006 to that in 2007?
Give a very brief answer. 1.17. What is the ratio of the Claims(annual growth as % of broad money) of St. Vincent and the Grenadines in 2006 to that in 2007?
Your response must be concise. 1.25. What is the ratio of the Claims(annual growth as % of broad money) of Belize in 2006 to that in 2008?
Keep it short and to the point. 1.08. What is the ratio of the Claims(annual growth as % of broad money) in Pakistan in 2006 to that in 2008?
Offer a terse response. 0.95. What is the ratio of the Claims(annual growth as % of broad money) in South Africa in 2006 to that in 2008?
Offer a very short reply. 1.7. What is the ratio of the Claims(annual growth as % of broad money) of St. Vincent and the Grenadines in 2006 to that in 2008?
Provide a succinct answer. 2.16. What is the ratio of the Claims(annual growth as % of broad money) in Belize in 2006 to that in 2009?
Offer a very short reply. 3. What is the ratio of the Claims(annual growth as % of broad money) of Pakistan in 2006 to that in 2009?
Offer a very short reply. 1.43. What is the ratio of the Claims(annual growth as % of broad money) of South Africa in 2006 to that in 2009?
Provide a short and direct response. 218.48. What is the ratio of the Claims(annual growth as % of broad money) in Pakistan in 2006 to that in 2010?
Offer a very short reply. 4.92. What is the ratio of the Claims(annual growth as % of broad money) of South Africa in 2006 to that in 2010?
Give a very brief answer. 3.98. What is the ratio of the Claims(annual growth as % of broad money) of Belize in 2006 to that in 2011?
Your answer should be compact. 11.34. What is the ratio of the Claims(annual growth as % of broad money) in South Africa in 2006 to that in 2011?
Offer a terse response. 4.62. What is the ratio of the Claims(annual growth as % of broad money) of St. Vincent and the Grenadines in 2006 to that in 2011?
Give a very brief answer. 7.46. What is the ratio of the Claims(annual growth as % of broad money) of Belize in 2006 to that in 2012?
Offer a terse response. 5. What is the ratio of the Claims(annual growth as % of broad money) of Pakistan in 2006 to that in 2012?
Offer a terse response. 2.45. What is the ratio of the Claims(annual growth as % of broad money) of South Africa in 2006 to that in 2012?
Make the answer very short. 2.54. What is the ratio of the Claims(annual growth as % of broad money) of St. Vincent and the Grenadines in 2006 to that in 2012?
Your answer should be compact. 3.93. What is the ratio of the Claims(annual growth as % of broad money) of Belize in 2006 to that in 2013?
Keep it short and to the point. 4.64. What is the ratio of the Claims(annual growth as % of broad money) of Pakistan in 2006 to that in 2013?
Offer a very short reply. 3.05. What is the ratio of the Claims(annual growth as % of broad money) of South Africa in 2006 to that in 2013?
Keep it short and to the point. 4.24. What is the ratio of the Claims(annual growth as % of broad money) of St. Vincent and the Grenadines in 2006 to that in 2013?
Provide a succinct answer. 13.96. What is the ratio of the Claims(annual growth as % of broad money) in Belize in 2007 to that in 2008?
Offer a terse response. 1.43. What is the ratio of the Claims(annual growth as % of broad money) in Pakistan in 2007 to that in 2008?
Provide a succinct answer. 0.99. What is the ratio of the Claims(annual growth as % of broad money) of South Africa in 2007 to that in 2008?
Your answer should be very brief. 1.46. What is the ratio of the Claims(annual growth as % of broad money) in St. Vincent and the Grenadines in 2007 to that in 2008?
Your response must be concise. 1.73. What is the ratio of the Claims(annual growth as % of broad money) in Belize in 2007 to that in 2009?
Offer a terse response. 3.97. What is the ratio of the Claims(annual growth as % of broad money) of Pakistan in 2007 to that in 2009?
Provide a succinct answer. 1.5. What is the ratio of the Claims(annual growth as % of broad money) in South Africa in 2007 to that in 2009?
Your response must be concise. 186.82. What is the ratio of the Claims(annual growth as % of broad money) of Pakistan in 2007 to that in 2010?
Keep it short and to the point. 5.13. What is the ratio of the Claims(annual growth as % of broad money) of South Africa in 2007 to that in 2010?
Provide a succinct answer. 3.41. What is the ratio of the Claims(annual growth as % of broad money) in Belize in 2007 to that in 2011?
Offer a very short reply. 15.03. What is the ratio of the Claims(annual growth as % of broad money) of South Africa in 2007 to that in 2011?
Provide a short and direct response. 3.95. What is the ratio of the Claims(annual growth as % of broad money) of St. Vincent and the Grenadines in 2007 to that in 2011?
Provide a succinct answer. 5.96. What is the ratio of the Claims(annual growth as % of broad money) of Belize in 2007 to that in 2012?
Your answer should be very brief. 6.63. What is the ratio of the Claims(annual growth as % of broad money) of Pakistan in 2007 to that in 2012?
Give a very brief answer. 2.55. What is the ratio of the Claims(annual growth as % of broad money) in South Africa in 2007 to that in 2012?
Your response must be concise. 2.18. What is the ratio of the Claims(annual growth as % of broad money) of St. Vincent and the Grenadines in 2007 to that in 2012?
Provide a short and direct response. 3.14. What is the ratio of the Claims(annual growth as % of broad money) of Belize in 2007 to that in 2013?
Provide a succinct answer. 6.16. What is the ratio of the Claims(annual growth as % of broad money) of Pakistan in 2007 to that in 2013?
Provide a succinct answer. 3.18. What is the ratio of the Claims(annual growth as % of broad money) in South Africa in 2007 to that in 2013?
Offer a very short reply. 3.62. What is the ratio of the Claims(annual growth as % of broad money) in St. Vincent and the Grenadines in 2007 to that in 2013?
Your answer should be compact. 11.14. What is the ratio of the Claims(annual growth as % of broad money) of Belize in 2008 to that in 2009?
Make the answer very short. 2.79. What is the ratio of the Claims(annual growth as % of broad money) of Pakistan in 2008 to that in 2009?
Give a very brief answer. 1.51. What is the ratio of the Claims(annual growth as % of broad money) of South Africa in 2008 to that in 2009?
Offer a terse response. 128.16. What is the ratio of the Claims(annual growth as % of broad money) of Pakistan in 2008 to that in 2010?
Your answer should be compact. 5.19. What is the ratio of the Claims(annual growth as % of broad money) of South Africa in 2008 to that in 2010?
Offer a very short reply. 2.34. What is the ratio of the Claims(annual growth as % of broad money) in Belize in 2008 to that in 2011?
Provide a short and direct response. 10.54. What is the ratio of the Claims(annual growth as % of broad money) of South Africa in 2008 to that in 2011?
Your answer should be very brief. 2.71. What is the ratio of the Claims(annual growth as % of broad money) in St. Vincent and the Grenadines in 2008 to that in 2011?
Your answer should be compact. 3.45. What is the ratio of the Claims(annual growth as % of broad money) in Belize in 2008 to that in 2012?
Provide a short and direct response. 4.65. What is the ratio of the Claims(annual growth as % of broad money) in Pakistan in 2008 to that in 2012?
Ensure brevity in your answer.  2.58. What is the ratio of the Claims(annual growth as % of broad money) in South Africa in 2008 to that in 2012?
Make the answer very short. 1.49. What is the ratio of the Claims(annual growth as % of broad money) in St. Vincent and the Grenadines in 2008 to that in 2012?
Provide a succinct answer. 1.82. What is the ratio of the Claims(annual growth as % of broad money) in Belize in 2008 to that in 2013?
Your answer should be very brief. 4.32. What is the ratio of the Claims(annual growth as % of broad money) of Pakistan in 2008 to that in 2013?
Make the answer very short. 3.21. What is the ratio of the Claims(annual growth as % of broad money) in South Africa in 2008 to that in 2013?
Your response must be concise. 2.49. What is the ratio of the Claims(annual growth as % of broad money) of St. Vincent and the Grenadines in 2008 to that in 2013?
Your response must be concise. 6.45. What is the ratio of the Claims(annual growth as % of broad money) in Pakistan in 2009 to that in 2010?
Offer a very short reply. 3.43. What is the ratio of the Claims(annual growth as % of broad money) in South Africa in 2009 to that in 2010?
Ensure brevity in your answer.  0.02. What is the ratio of the Claims(annual growth as % of broad money) in Belize in 2009 to that in 2011?
Offer a very short reply. 3.78. What is the ratio of the Claims(annual growth as % of broad money) of South Africa in 2009 to that in 2011?
Give a very brief answer. 0.02. What is the ratio of the Claims(annual growth as % of broad money) in Belize in 2009 to that in 2012?
Offer a very short reply. 1.67. What is the ratio of the Claims(annual growth as % of broad money) in Pakistan in 2009 to that in 2012?
Your answer should be very brief. 1.71. What is the ratio of the Claims(annual growth as % of broad money) in South Africa in 2009 to that in 2012?
Make the answer very short. 0.01. What is the ratio of the Claims(annual growth as % of broad money) of Belize in 2009 to that in 2013?
Make the answer very short. 1.55. What is the ratio of the Claims(annual growth as % of broad money) of Pakistan in 2009 to that in 2013?
Make the answer very short. 2.13. What is the ratio of the Claims(annual growth as % of broad money) in South Africa in 2009 to that in 2013?
Your answer should be compact. 0.02. What is the ratio of the Claims(annual growth as % of broad money) in South Africa in 2010 to that in 2011?
Your response must be concise. 1.16. What is the ratio of the Claims(annual growth as % of broad money) in Pakistan in 2010 to that in 2012?
Your answer should be very brief. 0.5. What is the ratio of the Claims(annual growth as % of broad money) of South Africa in 2010 to that in 2012?
Offer a terse response. 0.64. What is the ratio of the Claims(annual growth as % of broad money) of Pakistan in 2010 to that in 2013?
Your answer should be compact. 0.62. What is the ratio of the Claims(annual growth as % of broad money) in South Africa in 2010 to that in 2013?
Offer a terse response. 1.06. What is the ratio of the Claims(annual growth as % of broad money) of Belize in 2011 to that in 2012?
Provide a succinct answer. 0.44. What is the ratio of the Claims(annual growth as % of broad money) in South Africa in 2011 to that in 2012?
Your answer should be compact. 0.55. What is the ratio of the Claims(annual growth as % of broad money) in St. Vincent and the Grenadines in 2011 to that in 2012?
Your answer should be compact. 0.53. What is the ratio of the Claims(annual growth as % of broad money) in Belize in 2011 to that in 2013?
Your response must be concise. 0.41. What is the ratio of the Claims(annual growth as % of broad money) of South Africa in 2011 to that in 2013?
Your answer should be very brief. 0.92. What is the ratio of the Claims(annual growth as % of broad money) of St. Vincent and the Grenadines in 2011 to that in 2013?
Your answer should be compact. 1.87. What is the ratio of the Claims(annual growth as % of broad money) of Belize in 2012 to that in 2013?
Give a very brief answer. 0.93. What is the ratio of the Claims(annual growth as % of broad money) of Pakistan in 2012 to that in 2013?
Ensure brevity in your answer.  1.25. What is the ratio of the Claims(annual growth as % of broad money) of South Africa in 2012 to that in 2013?
Offer a terse response. 1.67. What is the ratio of the Claims(annual growth as % of broad money) of St. Vincent and the Grenadines in 2012 to that in 2013?
Your response must be concise. 3.55. What is the difference between the highest and the second highest Claims(annual growth as % of broad money) in Belize?
Keep it short and to the point. 3.24. What is the difference between the highest and the second highest Claims(annual growth as % of broad money) in Pakistan?
Your response must be concise. 0.12. What is the difference between the highest and the second highest Claims(annual growth as % of broad money) in South Africa?
Offer a terse response. 3.94. What is the difference between the highest and the second highest Claims(annual growth as % of broad money) in St. Vincent and the Grenadines?
Keep it short and to the point. 2.32. What is the difference between the highest and the lowest Claims(annual growth as % of broad money) of Belize?
Offer a very short reply. 13.2. What is the difference between the highest and the lowest Claims(annual growth as % of broad money) of Pakistan?
Ensure brevity in your answer.  12.11. What is the difference between the highest and the lowest Claims(annual growth as % of broad money) of South Africa?
Ensure brevity in your answer.  27.05. What is the difference between the highest and the lowest Claims(annual growth as % of broad money) in St. Vincent and the Grenadines?
Your response must be concise. 11.51. 